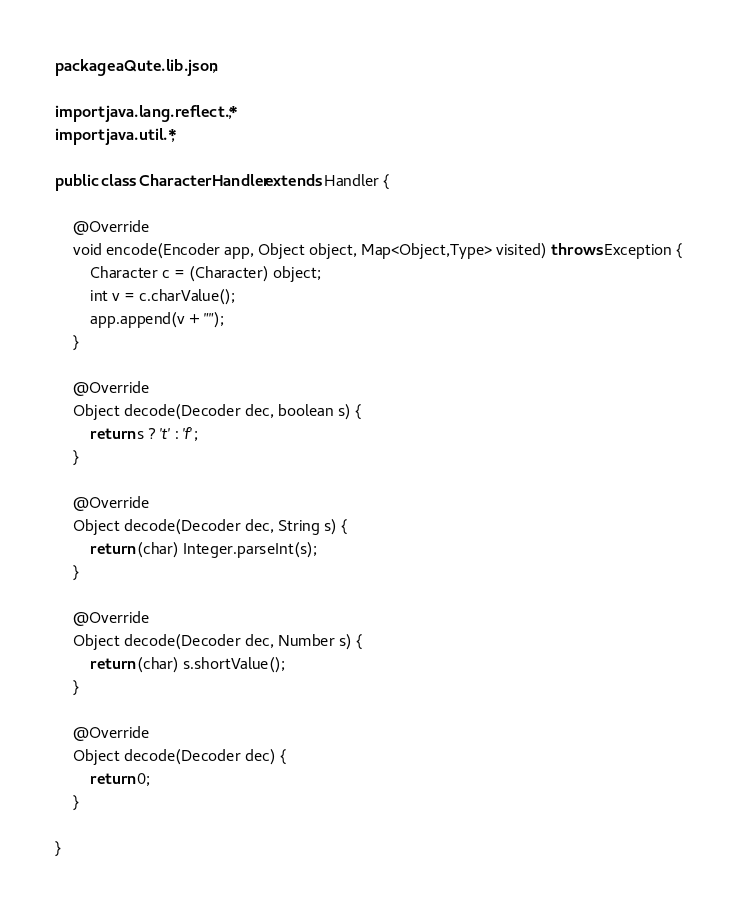Convert code to text. <code><loc_0><loc_0><loc_500><loc_500><_Java_>package aQute.lib.json;

import java.lang.reflect.*;
import java.util.*;

public class CharacterHandler extends Handler {

	@Override
	void encode(Encoder app, Object object, Map<Object,Type> visited) throws Exception {
		Character c = (Character) object;
		int v = c.charValue();
		app.append(v + "");
	}

	@Override
	Object decode(Decoder dec, boolean s) {
		return s ? 't' : 'f';
	}

	@Override
	Object decode(Decoder dec, String s) {
		return (char) Integer.parseInt(s);
	}

	@Override
	Object decode(Decoder dec, Number s) {
		return (char) s.shortValue();
	}

	@Override
	Object decode(Decoder dec) {
		return 0;
	}

}
</code> 